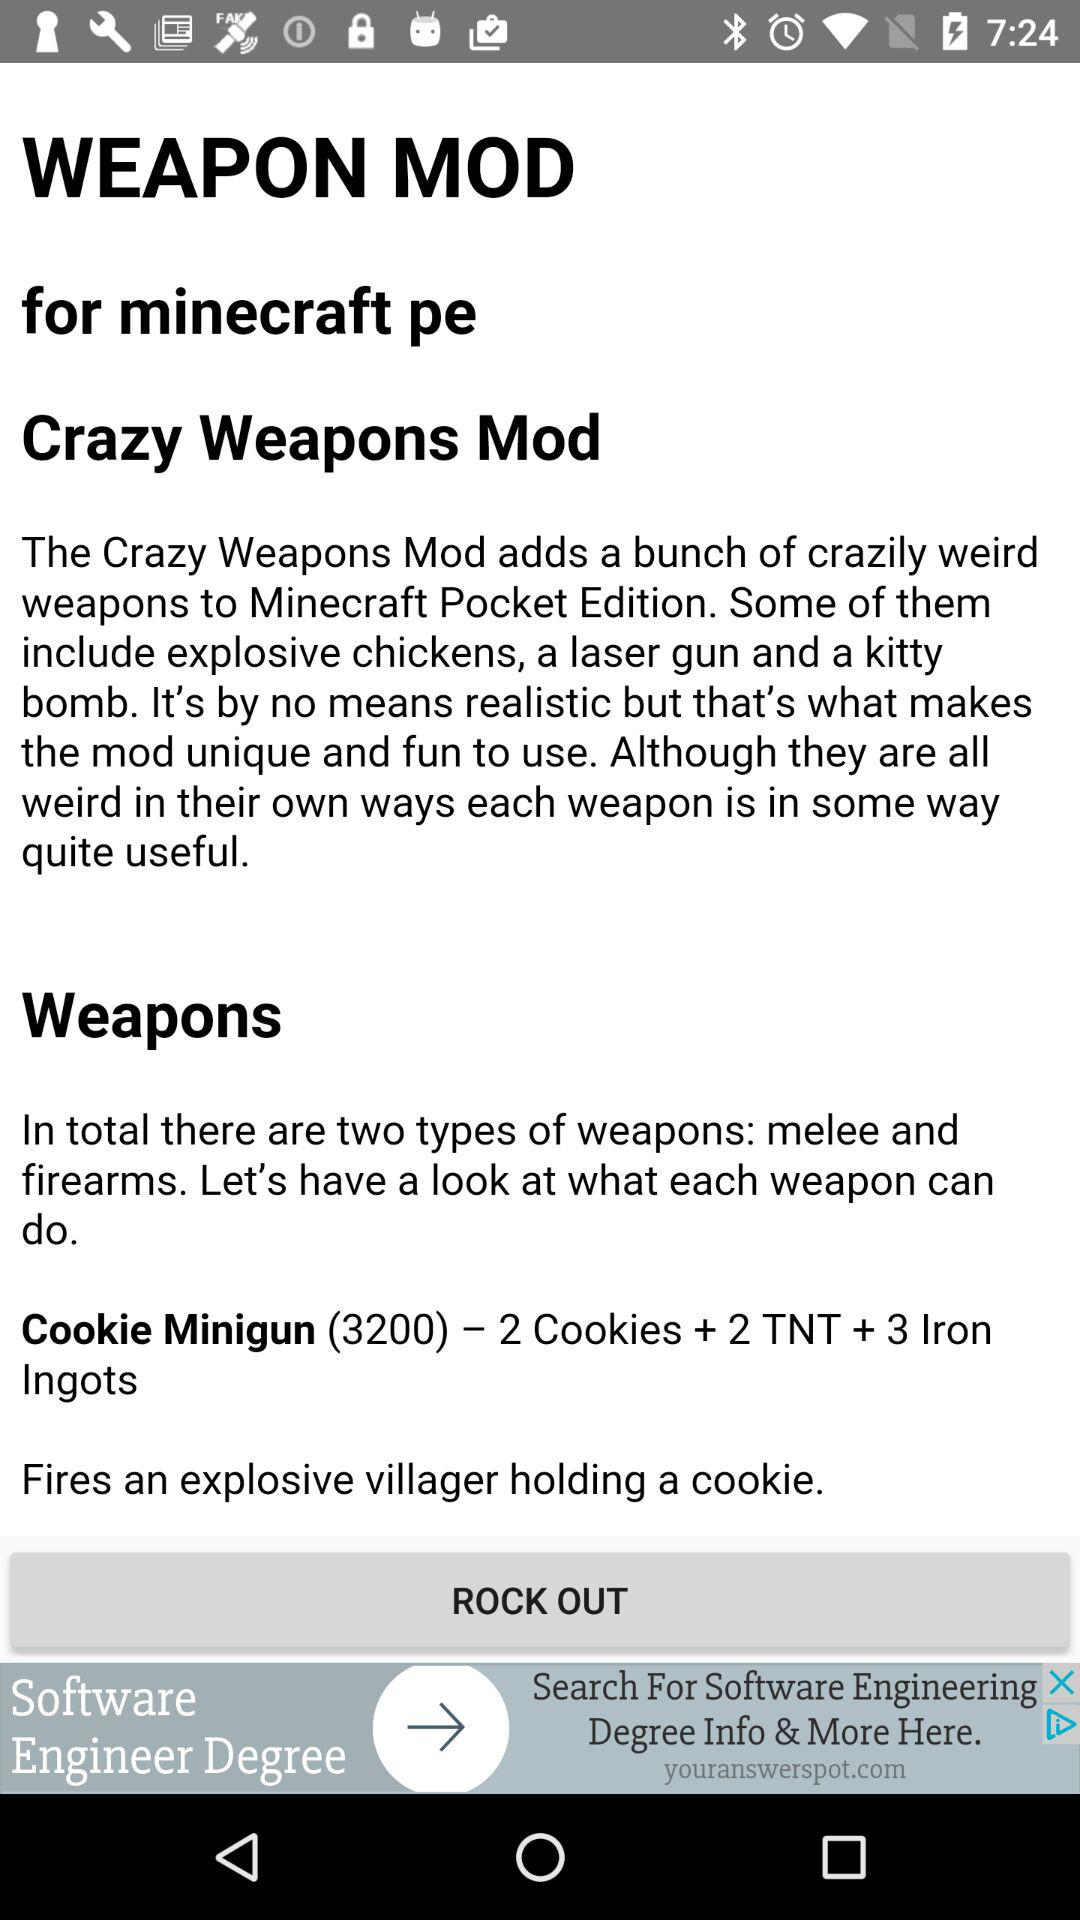What are the types of weapons? The types of weapons are melee and firearms. 